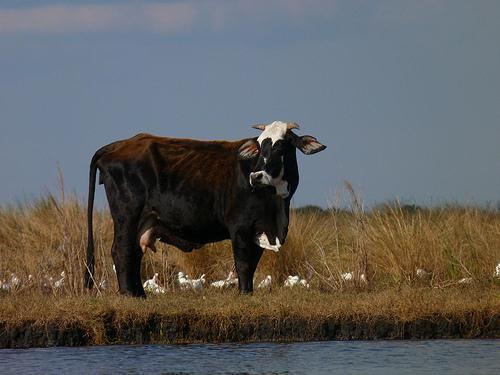How many animals?
Give a very brief answer. 1. 